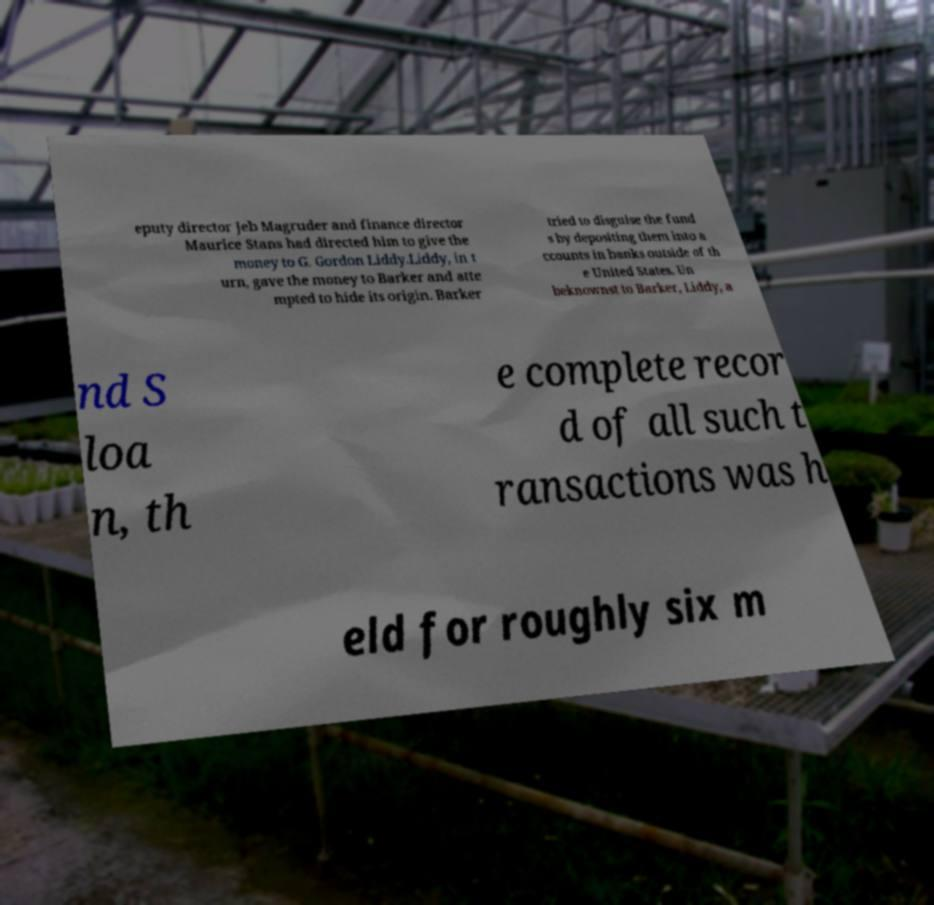There's text embedded in this image that I need extracted. Can you transcribe it verbatim? eputy director Jeb Magruder and finance director Maurice Stans had directed him to give the money to G. Gordon Liddy.Liddy, in t urn, gave the money to Barker and atte mpted to hide its origin. Barker tried to disguise the fund s by depositing them into a ccounts in banks outside of th e United States. Un beknownst to Barker, Liddy, a nd S loa n, th e complete recor d of all such t ransactions was h eld for roughly six m 